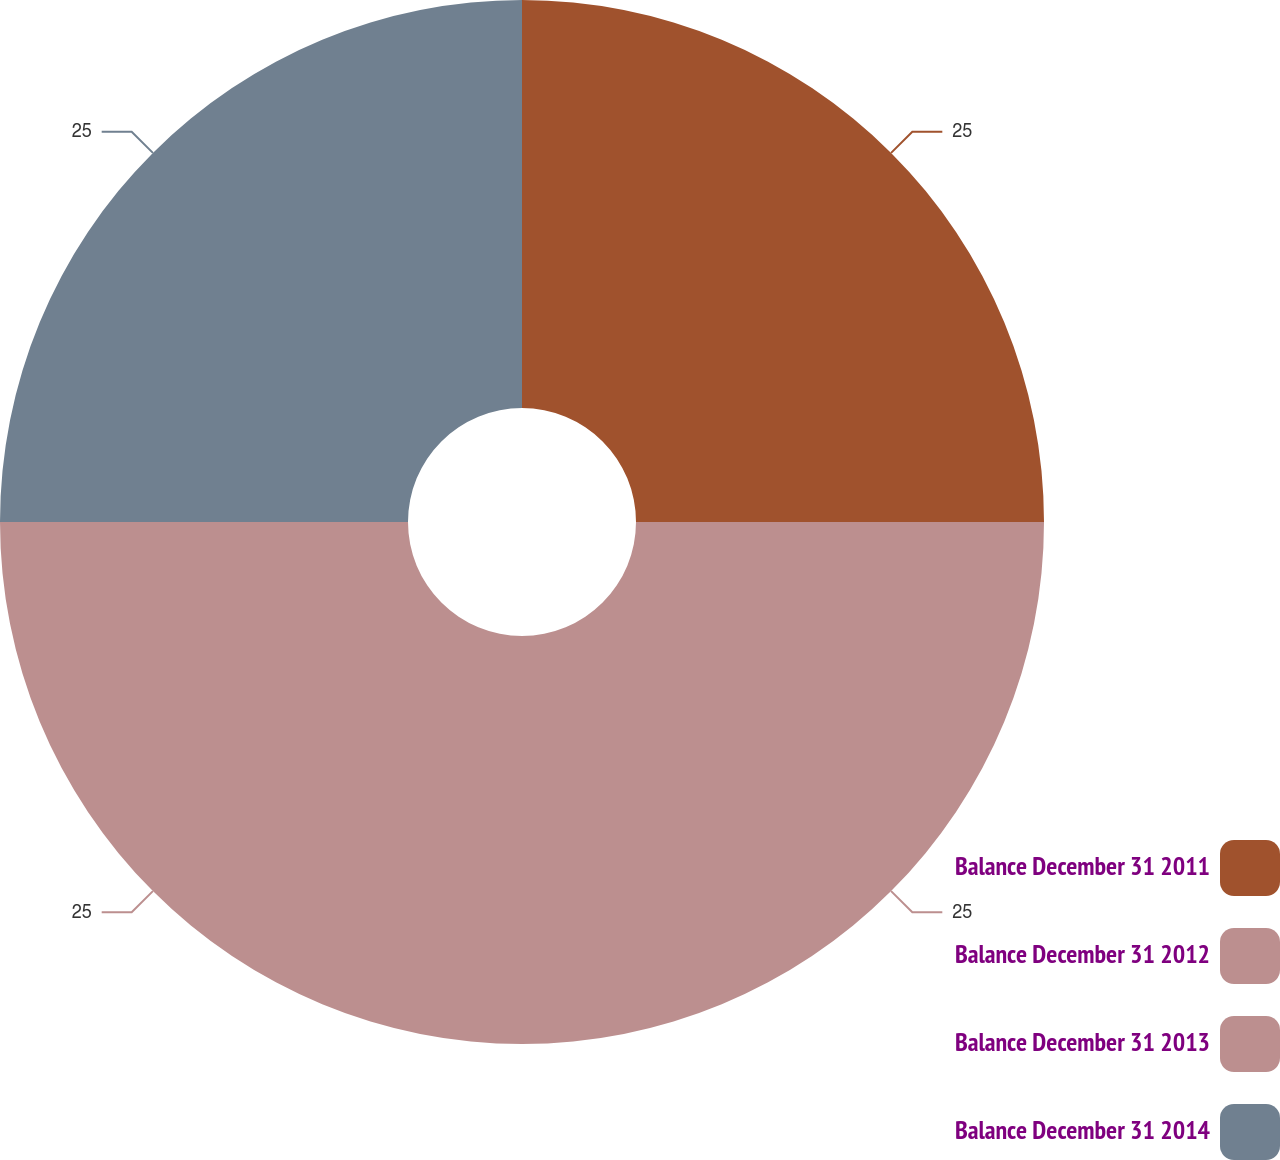Convert chart. <chart><loc_0><loc_0><loc_500><loc_500><pie_chart><fcel>Balance December 31 2011<fcel>Balance December 31 2012<fcel>Balance December 31 2013<fcel>Balance December 31 2014<nl><fcel>25.0%<fcel>25.0%<fcel>25.0%<fcel>25.0%<nl></chart> 